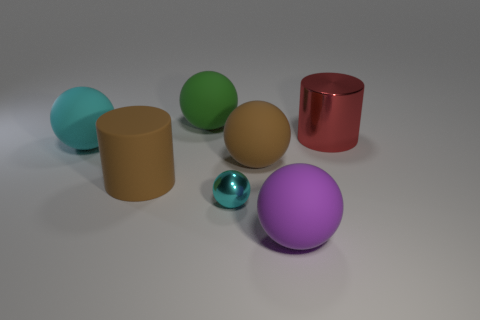Subtract all big brown matte balls. How many balls are left? 4 Subtract 1 balls. How many balls are left? 4 Subtract all yellow balls. Subtract all gray blocks. How many balls are left? 5 Add 3 small yellow matte cylinders. How many objects exist? 10 Subtract all balls. How many objects are left? 2 Subtract all purple things. Subtract all matte things. How many objects are left? 1 Add 2 brown things. How many brown things are left? 4 Add 2 cylinders. How many cylinders exist? 4 Subtract 0 yellow blocks. How many objects are left? 7 